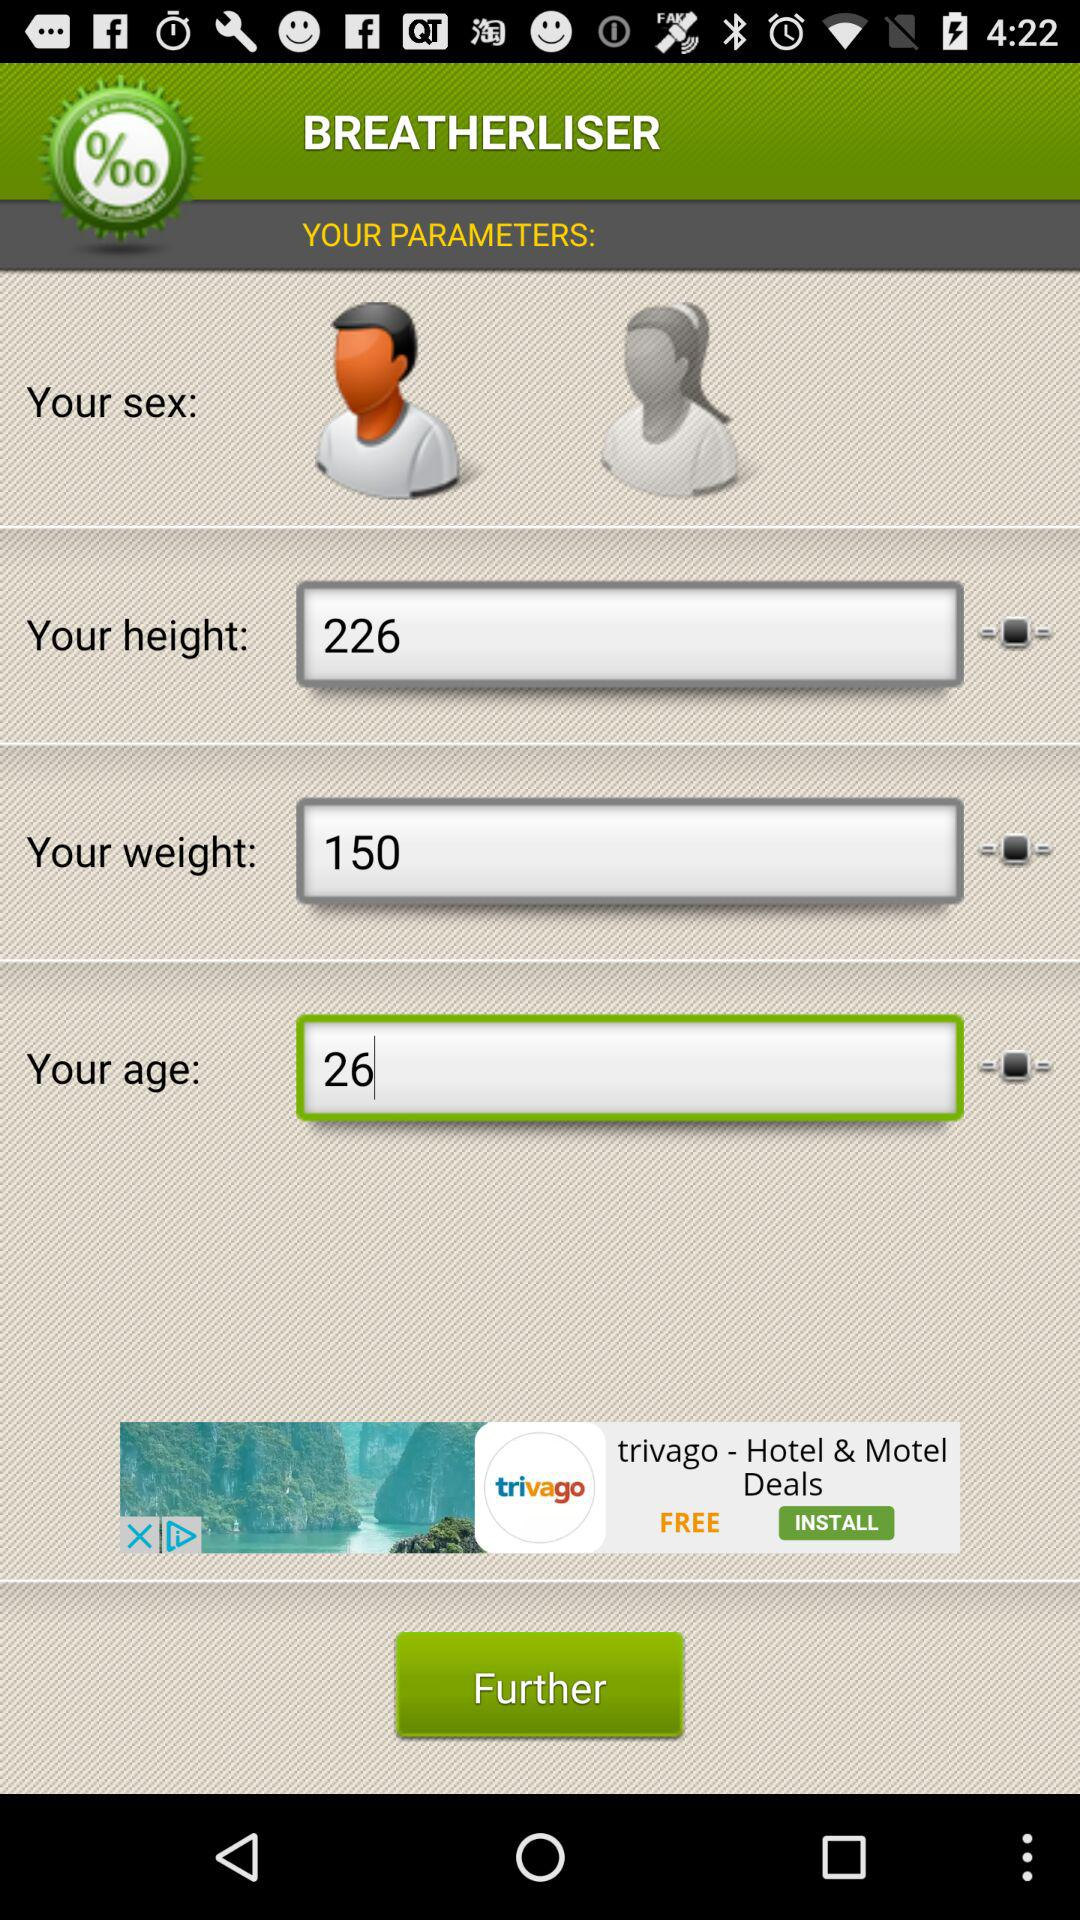How many sex options are there?
Answer the question using a single word or phrase. 2 